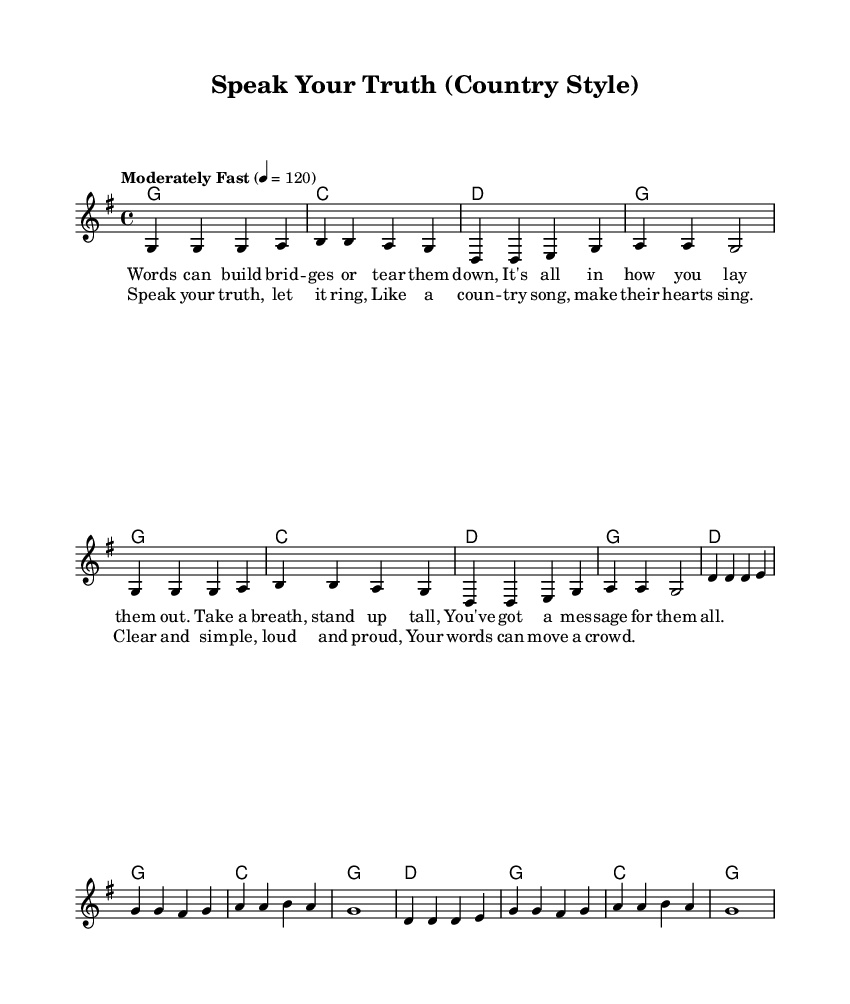What is the key signature of this music? The key signature is indicated by the "key g major" statement found in the global section. It shows one sharp (F#), which defines the G major scale.
Answer: G major What is the time signature of this music? The time signature is specified by the "time 4/4" statement in the global section, indicating four beats in a measure and a quarter note gets one beat.
Answer: 4/4 What is the tempo marking for this music? The tempo is marked as "Moderately Fast" with a metronome marking of 4 = 120. This gives us the tempo's feel and specific speed in beats per minute.
Answer: Moderately Fast How many measures are in the chorus section? The chorus is comprised of a total of two repetitions of the same musical phrases, with each phrase containing four measures, resulting in 8 measures overall in the chorus.
Answer: 8 Which chord appears first in the verse? The first chord indicated in the verse lines is a G major chord, as shown in the harmonies section, and appears as the first element in the verse sequence.
Answer: G What is the main theme of the lyrics in the verse? The lyrics convey a theme about the power of words, emphasizing their ability to connect or disconnect people, highlighting the importance of effective communication.
Answer: Communicating powerfully What stylistic element is prominent in the chorus's lyrics? The lyrics of the chorus emphasize clarity and pride in expression, which is a characteristic feature in many country songs that focus on personal storytelling and emotional resonance.
Answer: Clarity and pride 